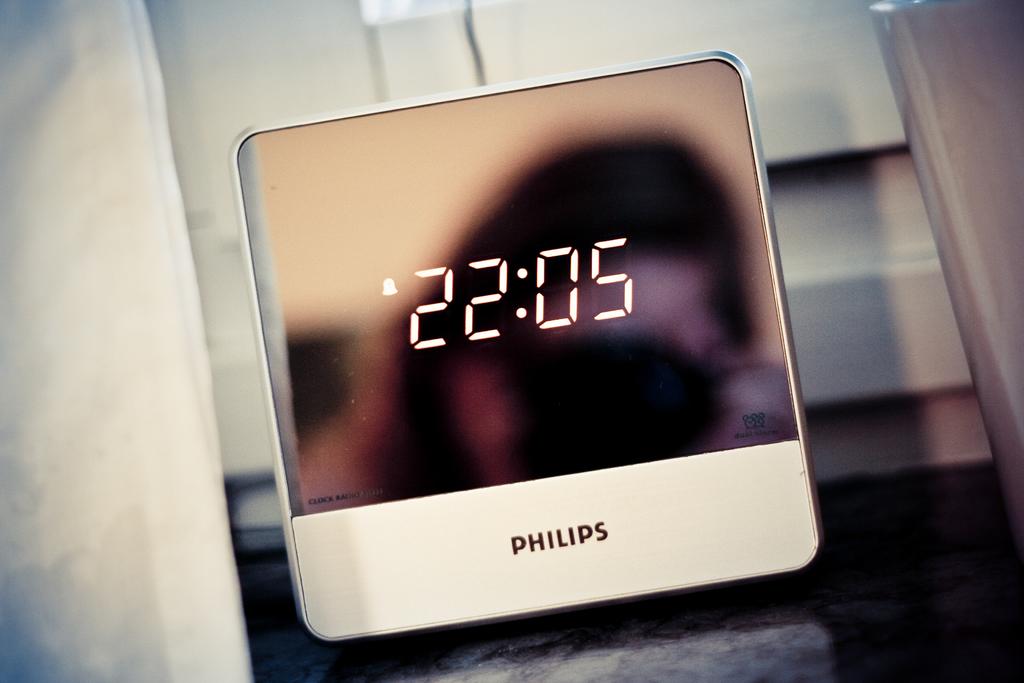What time is it?
Provide a succinct answer. 22:05. What brand of clock is this?
Provide a succinct answer. Philips. 